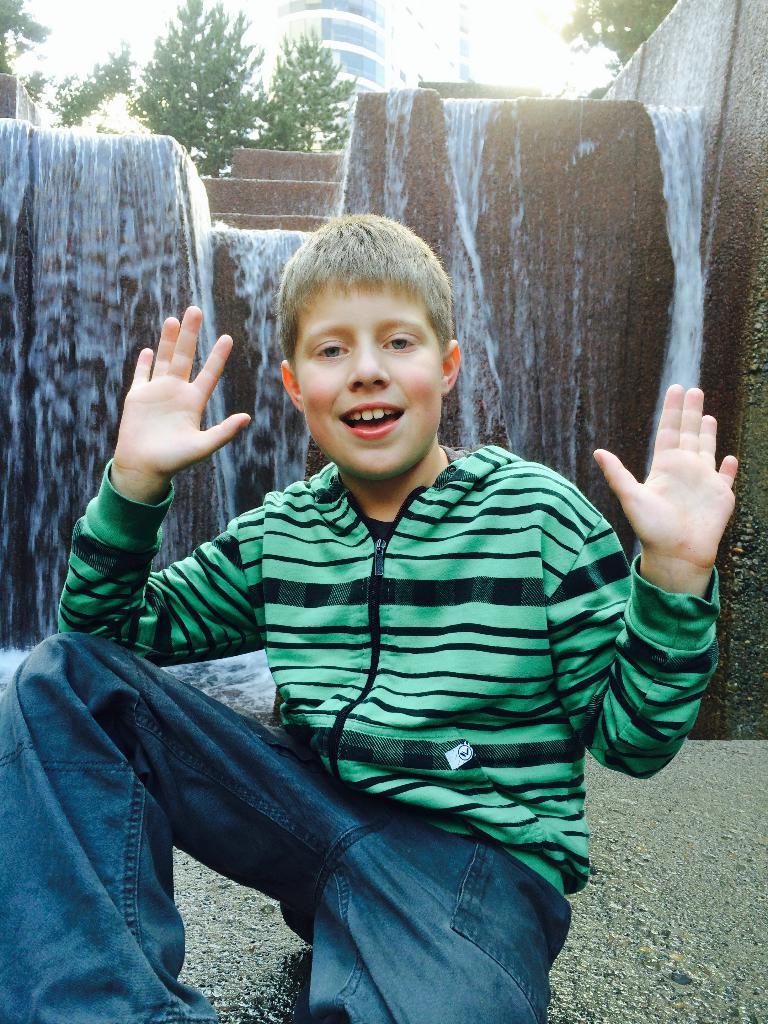Describe this image in one or two sentences. In the foreground of the picture there is a boy, behind him there is a waterfall. In the background there are trees and building. 